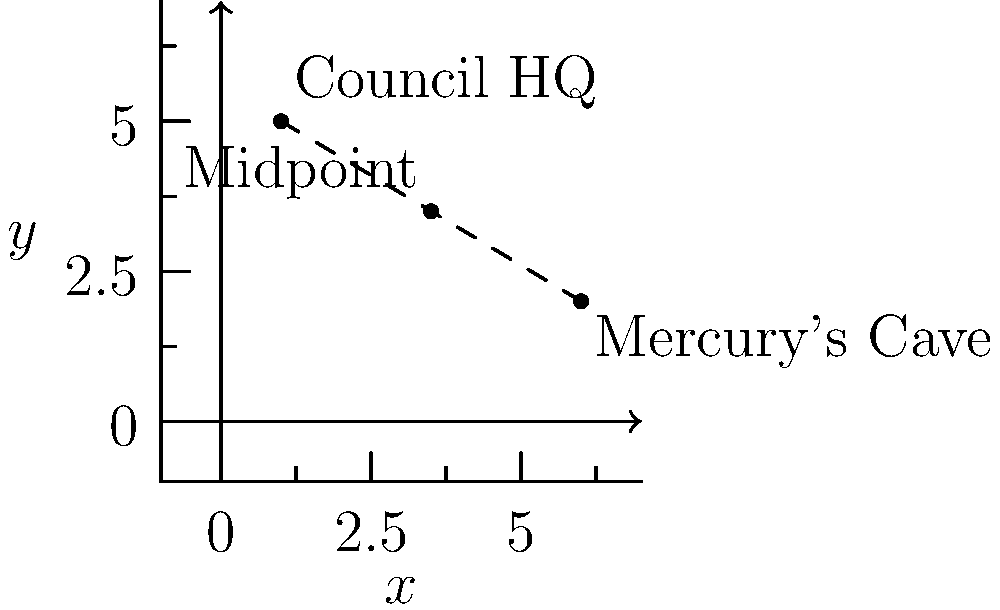In the "Half Bad" universe, the Council Headquarters is located at coordinates (1, 5), while Mercury's Cave is at (6, 2). Nathan often travels between these two locations. What are the coordinates of the midpoint between these two significant places? To find the midpoint between two points, we need to follow these steps:

1. Identify the coordinates of the two points:
   - Council HQ: $(x_1, y_1) = (1, 5)$
   - Mercury's Cave: $(x_2, y_2) = (6, 2)$

2. Use the midpoint formula:
   The midpoint formula is: $(\frac{x_1 + x_2}{2}, \frac{y_1 + y_2}{2})$

3. Calculate the x-coordinate of the midpoint:
   $x = \frac{x_1 + x_2}{2} = \frac{1 + 6}{2} = \frac{7}{2} = 3.5$

4. Calculate the y-coordinate of the midpoint:
   $y = \frac{y_1 + y_2}{2} = \frac{5 + 2}{2} = \frac{7}{2} = 3.5$

5. Combine the results:
   The midpoint coordinates are $(3.5, 3.5)$

This point represents the exact middle of Nathan's journey between the Council Headquarters and Mercury's Cave.
Answer: $(3.5, 3.5)$ 